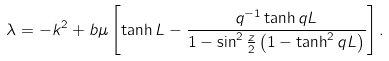<formula> <loc_0><loc_0><loc_500><loc_500>\lambda = - k ^ { 2 } + b \mu \left [ \tanh L - \frac { q ^ { - 1 } \tanh q L } { 1 - \sin ^ { 2 } \frac { z } { 2 } \left ( 1 - \tanh ^ { 2 } q L \right ) } \right ] .</formula> 